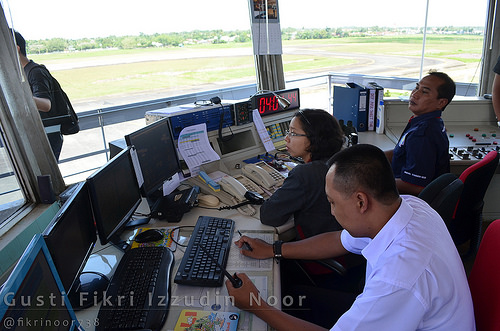<image>
Is the paper behind the woman? No. The paper is not behind the woman. From this viewpoint, the paper appears to be positioned elsewhere in the scene. Is there a laptop in front of the man? Yes. The laptop is positioned in front of the man, appearing closer to the camera viewpoint. Is the monitor in front of the woman? Yes. The monitor is positioned in front of the woman, appearing closer to the camera viewpoint. Is the man in front of the women? Yes. The man is positioned in front of the women, appearing closer to the camera viewpoint. 